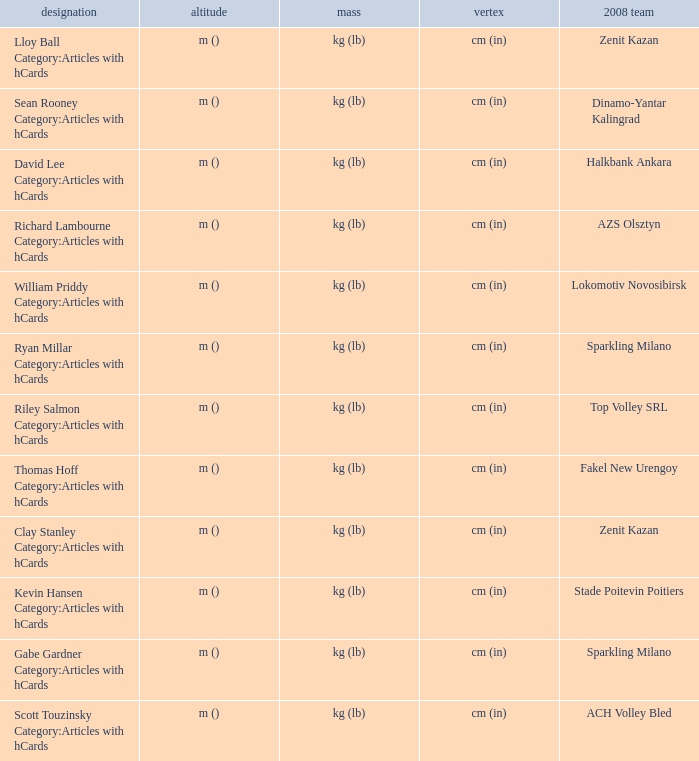What shows for height for the 2008 club of Stade Poitevin Poitiers? M (). 